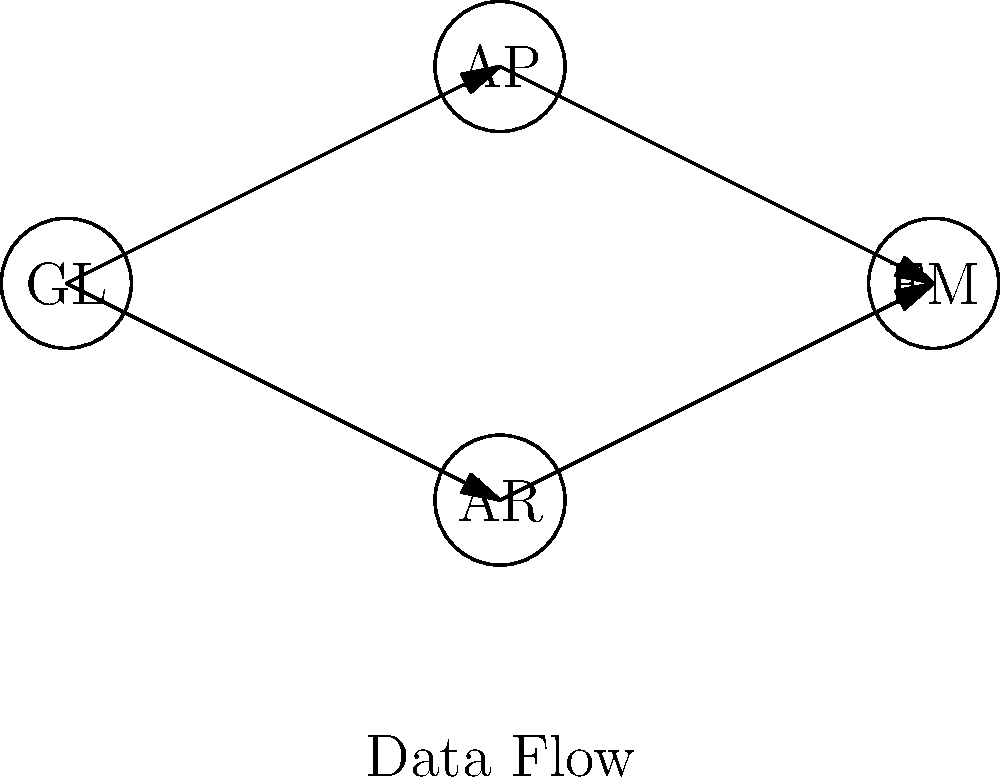In the given ERP system's financial module data flow diagram, which component serves as the central hub for financial data and feeds information to both Accounts Payable (AP) and Accounts Receivable (AR)? To answer this question, let's analyze the data flow diagram step-by-step:

1. The diagram shows four main components of an ERP system's financial module:
   - GL (General Ledger)
   - AP (Accounts Payable)
   - AR (Accounts Receivable)
   - FM (Financial Management)

2. We can observe the following data flow connections:
   - GL has outgoing arrows to both AP and AR
   - AP and AR have outgoing arrows to FM

3. The question asks about a component that:
   a) Serves as a central hub for financial data
   b) Feeds information to both AP and AR

4. Looking at the diagram, we can see that GL (General Ledger) is the only component that has outgoing arrows to both AP and AR.

5. In ERP systems, the General Ledger typically acts as the central repository for all financial data, which aligns with its position in this diagram.

6. The data flow from GL to both AP and AR indicates that the General Ledger is providing necessary financial information to these sub-modules for their specific functions.

Therefore, based on the diagram and our understanding of ERP financial modules, the component that serves as the central hub and feeds information to both AP and AR is the General Ledger (GL).
Answer: General Ledger (GL) 